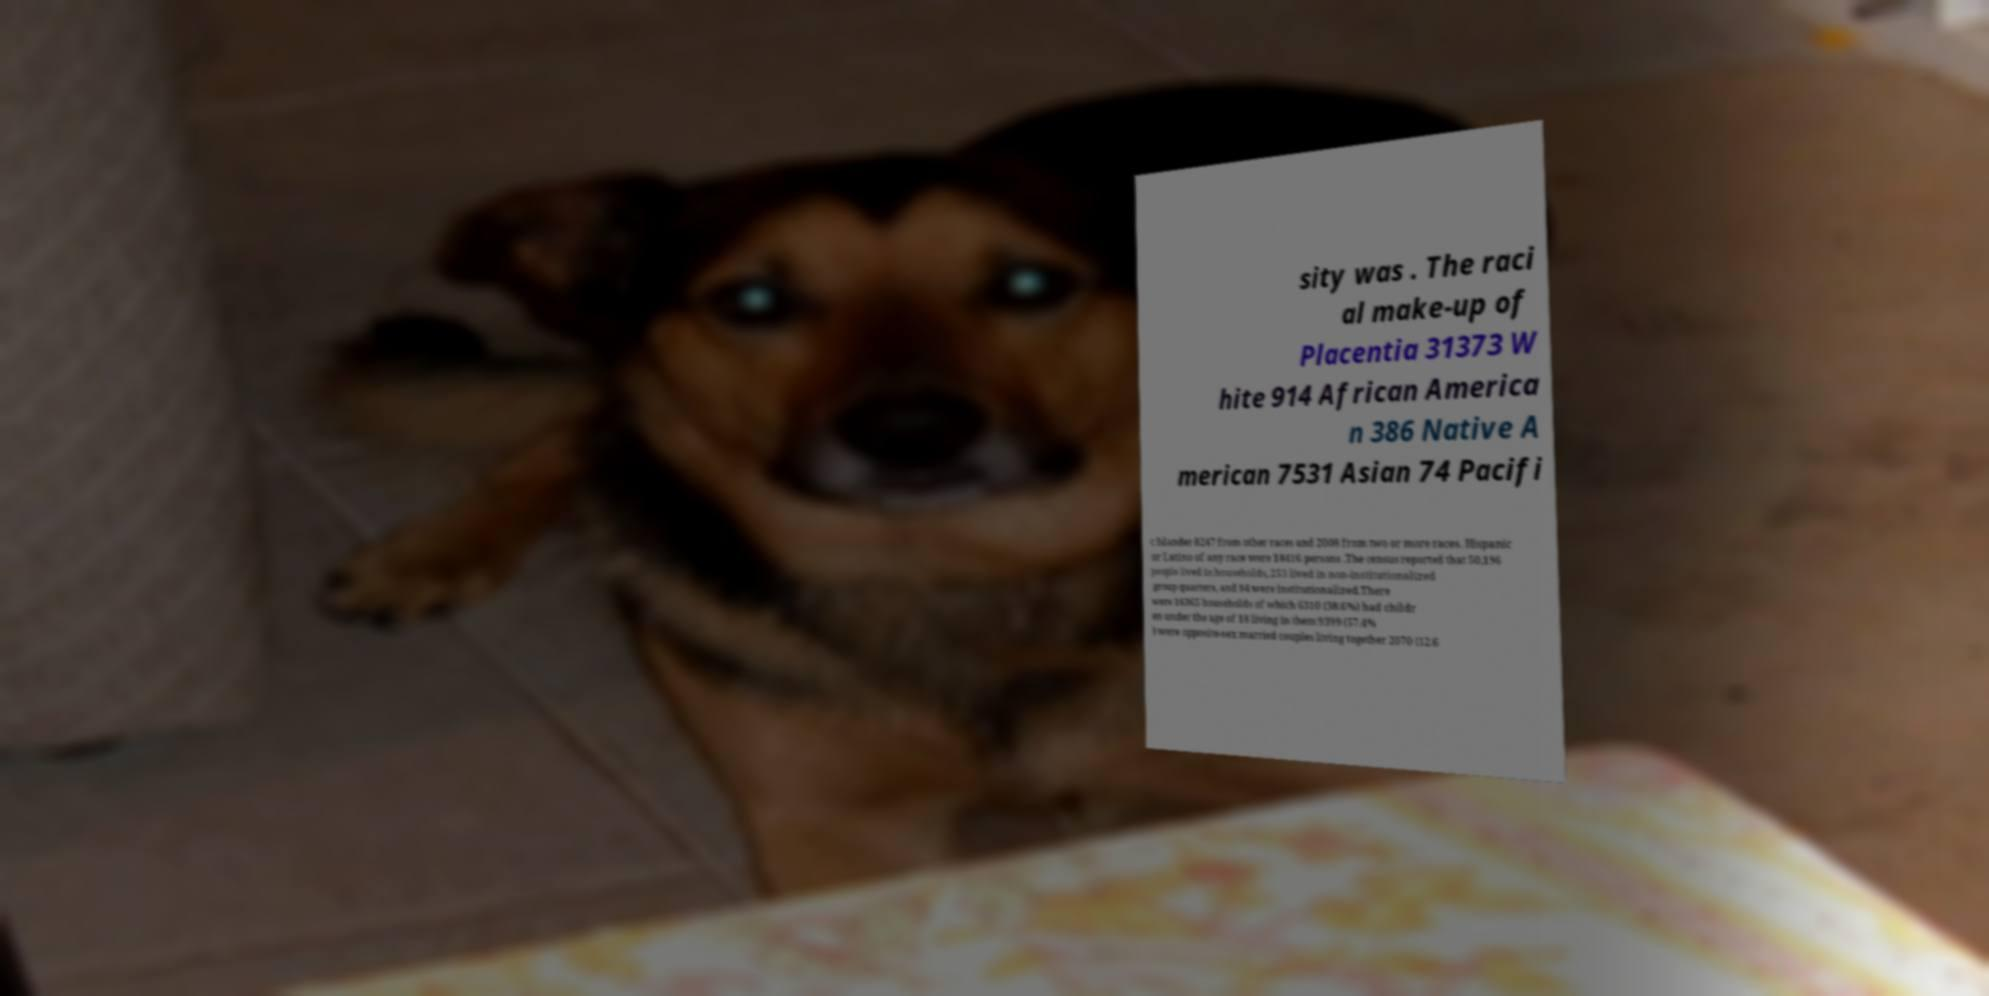Could you assist in decoding the text presented in this image and type it out clearly? sity was . The raci al make-up of Placentia 31373 W hite 914 African America n 386 Native A merican 7531 Asian 74 Pacifi c Islander 8247 from other races and 2008 from two or more races. Hispanic or Latino of any race were 18416 persons .The census reported that 50,196 people lived in households, 253 lived in non-institutionalized group quarters, and 84 were institutionalized.There were 16365 households of which 6310 (38.6%) had childr en under the age of 18 living in them 9399 (57.4% ) were opposite-sex married couples living together 2070 (12.6 